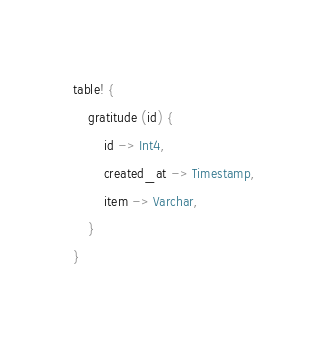<code> <loc_0><loc_0><loc_500><loc_500><_Rust_>table! {
    gratitude (id) {
        id -> Int4,
        created_at -> Timestamp,
        item -> Varchar,
    }
}
</code> 